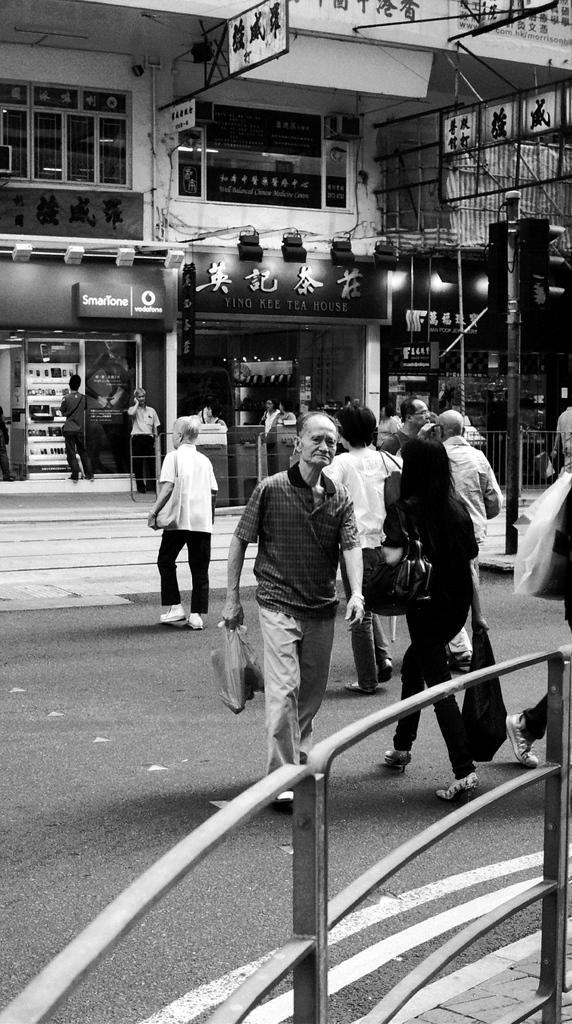Can you describe this image briefly? This is a black and white picture and there are few persons on the road. There is a pole and this is a fence. In the background we can see boards and buildings. 